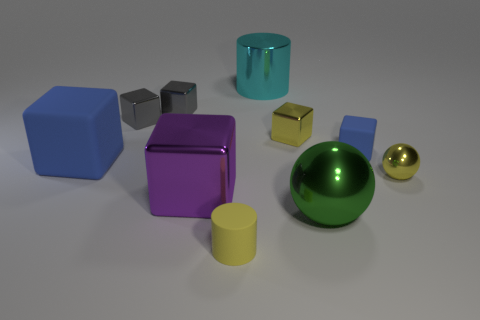Are there any objects in this image that could float on water? Though it's not certain without knowing the objects' materials, the teal cylinder and the yellow cube appear to be less dense and might be able to float on water depending on their composition. Could you guess what material they might be made from that would allow them to float? If we were to guess based on appearance, the teal cylinder might be made of plastic, and the yellow cube could be a light metallic or plastic foam, which would make them buoyant. 